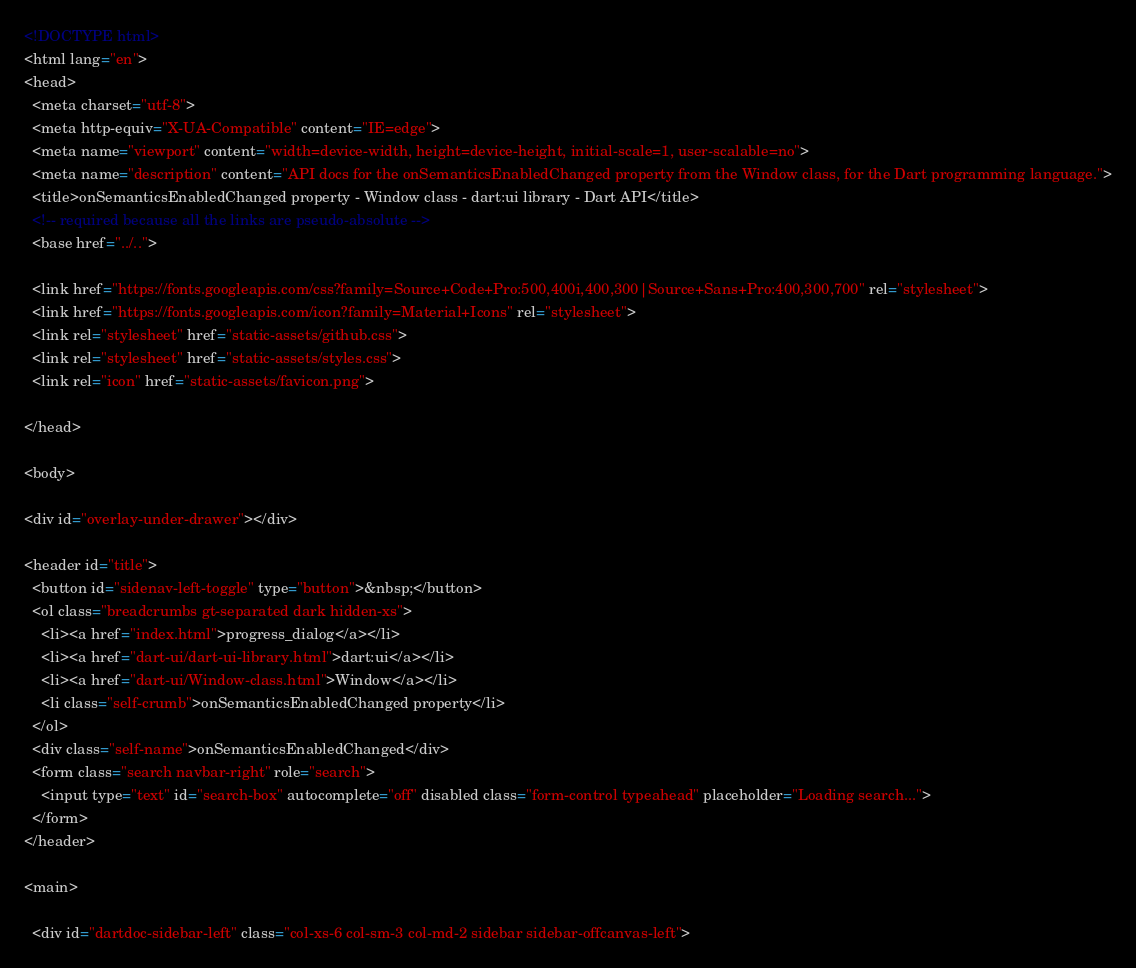<code> <loc_0><loc_0><loc_500><loc_500><_HTML_><!DOCTYPE html>
<html lang="en">
<head>
  <meta charset="utf-8">
  <meta http-equiv="X-UA-Compatible" content="IE=edge">
  <meta name="viewport" content="width=device-width, height=device-height, initial-scale=1, user-scalable=no">
  <meta name="description" content="API docs for the onSemanticsEnabledChanged property from the Window class, for the Dart programming language.">
  <title>onSemanticsEnabledChanged property - Window class - dart:ui library - Dart API</title>
  <!-- required because all the links are pseudo-absolute -->
  <base href="../..">

  <link href="https://fonts.googleapis.com/css?family=Source+Code+Pro:500,400i,400,300|Source+Sans+Pro:400,300,700" rel="stylesheet">
  <link href="https://fonts.googleapis.com/icon?family=Material+Icons" rel="stylesheet">
  <link rel="stylesheet" href="static-assets/github.css">
  <link rel="stylesheet" href="static-assets/styles.css">
  <link rel="icon" href="static-assets/favicon.png">
  
</head>

<body>

<div id="overlay-under-drawer"></div>

<header id="title">
  <button id="sidenav-left-toggle" type="button">&nbsp;</button>
  <ol class="breadcrumbs gt-separated dark hidden-xs">
    <li><a href="index.html">progress_dialog</a></li>
    <li><a href="dart-ui/dart-ui-library.html">dart:ui</a></li>
    <li><a href="dart-ui/Window-class.html">Window</a></li>
    <li class="self-crumb">onSemanticsEnabledChanged property</li>
  </ol>
  <div class="self-name">onSemanticsEnabledChanged</div>
  <form class="search navbar-right" role="search">
    <input type="text" id="search-box" autocomplete="off" disabled class="form-control typeahead" placeholder="Loading search...">
  </form>
</header>

<main>

  <div id="dartdoc-sidebar-left" class="col-xs-6 col-sm-3 col-md-2 sidebar sidebar-offcanvas-left"></code> 